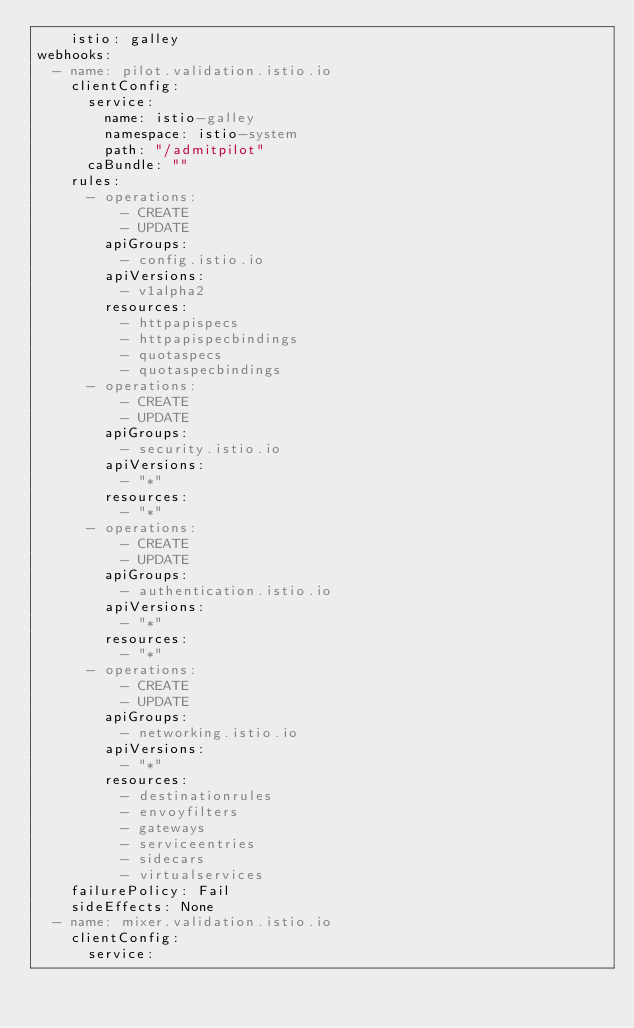Convert code to text. <code><loc_0><loc_0><loc_500><loc_500><_YAML_>    istio: galley
webhooks:
  - name: pilot.validation.istio.io
    clientConfig:
      service:
        name: istio-galley
        namespace: istio-system
        path: "/admitpilot"
      caBundle: ""
    rules:
      - operations:
          - CREATE
          - UPDATE
        apiGroups:
          - config.istio.io
        apiVersions:
          - v1alpha2
        resources:
          - httpapispecs
          - httpapispecbindings
          - quotaspecs
          - quotaspecbindings
      - operations:
          - CREATE
          - UPDATE
        apiGroups:
          - security.istio.io
        apiVersions:
          - "*"
        resources:
          - "*"
      - operations:
          - CREATE
          - UPDATE
        apiGroups:
          - authentication.istio.io
        apiVersions:
          - "*"
        resources:
          - "*"
      - operations:
          - CREATE
          - UPDATE
        apiGroups:
          - networking.istio.io
        apiVersions:
          - "*"
        resources:
          - destinationrules
          - envoyfilters
          - gateways
          - serviceentries
          - sidecars
          - virtualservices
    failurePolicy: Fail
    sideEffects: None
  - name: mixer.validation.istio.io
    clientConfig:
      service:</code> 